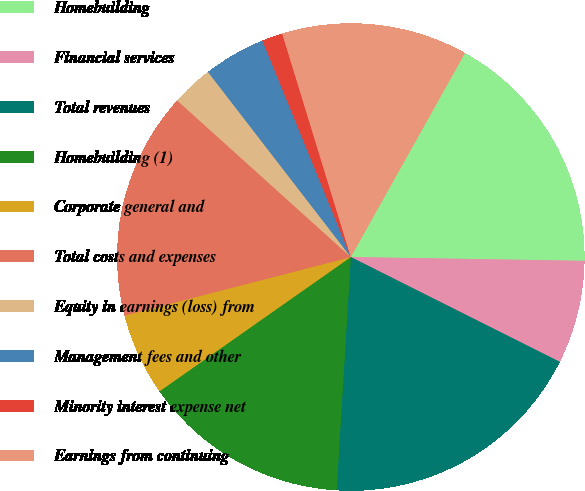Convert chart. <chart><loc_0><loc_0><loc_500><loc_500><pie_chart><fcel>Homebuilding<fcel>Financial services<fcel>Total revenues<fcel>Homebuilding (1)<fcel>Corporate general and<fcel>Total costs and expenses<fcel>Equity in earnings (loss) from<fcel>Management fees and other<fcel>Minority interest expense net<fcel>Earnings from continuing<nl><fcel>17.14%<fcel>7.14%<fcel>18.57%<fcel>14.29%<fcel>5.71%<fcel>15.71%<fcel>2.86%<fcel>4.29%<fcel>1.43%<fcel>12.86%<nl></chart> 